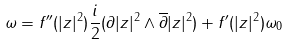Convert formula to latex. <formula><loc_0><loc_0><loc_500><loc_500>\omega = f ^ { \prime \prime } ( | z | ^ { 2 } ) \frac { i } { 2 } ( \partial | z | ^ { 2 } \wedge \overline { \partial } | z | ^ { 2 } ) + f ^ { \prime } ( | z | ^ { 2 } ) \omega _ { 0 }</formula> 